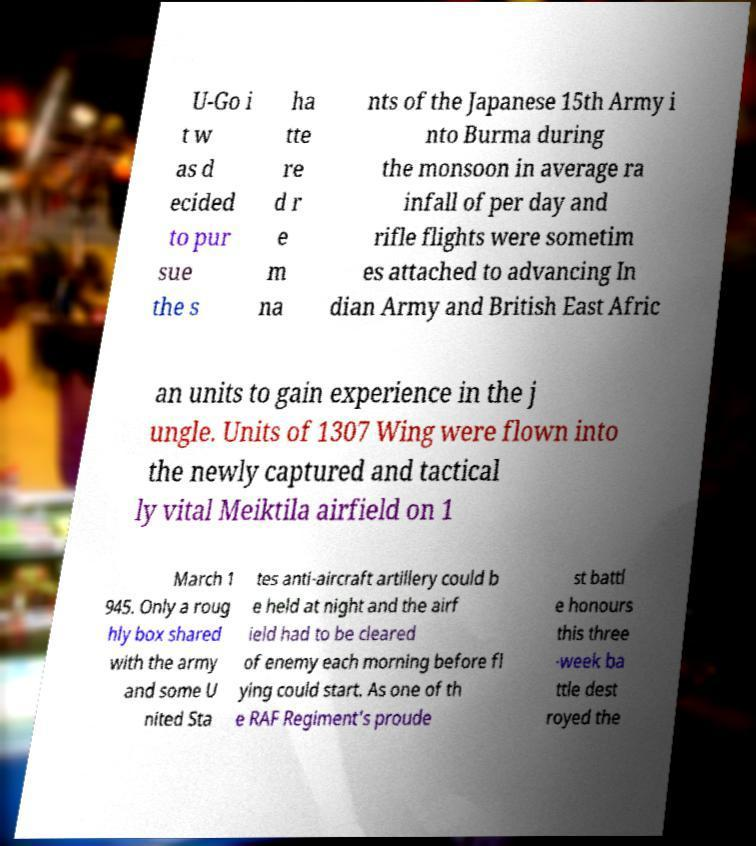What messages or text are displayed in this image? I need them in a readable, typed format. U-Go i t w as d ecided to pur sue the s ha tte re d r e m na nts of the Japanese 15th Army i nto Burma during the monsoon in average ra infall of per day and rifle flights were sometim es attached to advancing In dian Army and British East Afric an units to gain experience in the j ungle. Units of 1307 Wing were flown into the newly captured and tactical ly vital Meiktila airfield on 1 March 1 945. Only a roug hly box shared with the army and some U nited Sta tes anti-aircraft artillery could b e held at night and the airf ield had to be cleared of enemy each morning before fl ying could start. As one of th e RAF Regiment's proude st battl e honours this three -week ba ttle dest royed the 